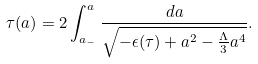Convert formula to latex. <formula><loc_0><loc_0><loc_500><loc_500>\tau ( a ) = 2 \int _ { a _ { - } } ^ { a } \frac { d a } { \sqrt { - \epsilon ( \tau ) + a ^ { 2 } - \frac { \Lambda } { 3 } a ^ { 4 } } } .</formula> 